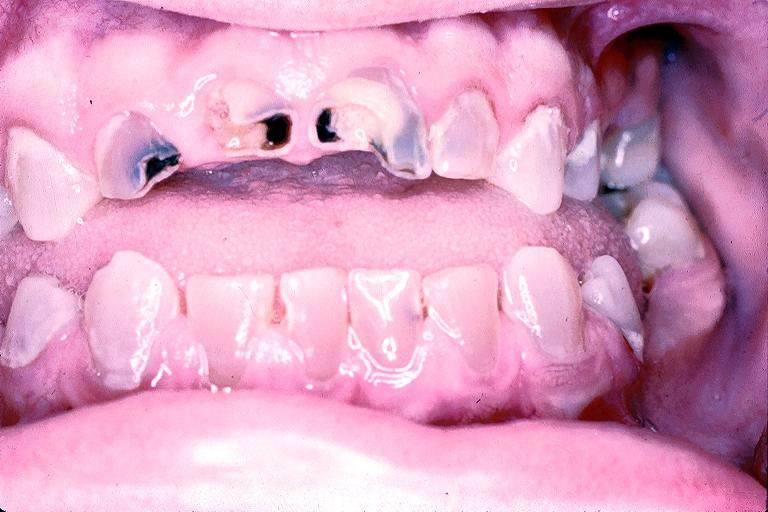what does this image show?
Answer the question using a single word or phrase. Dentinogenesis imperfecta 